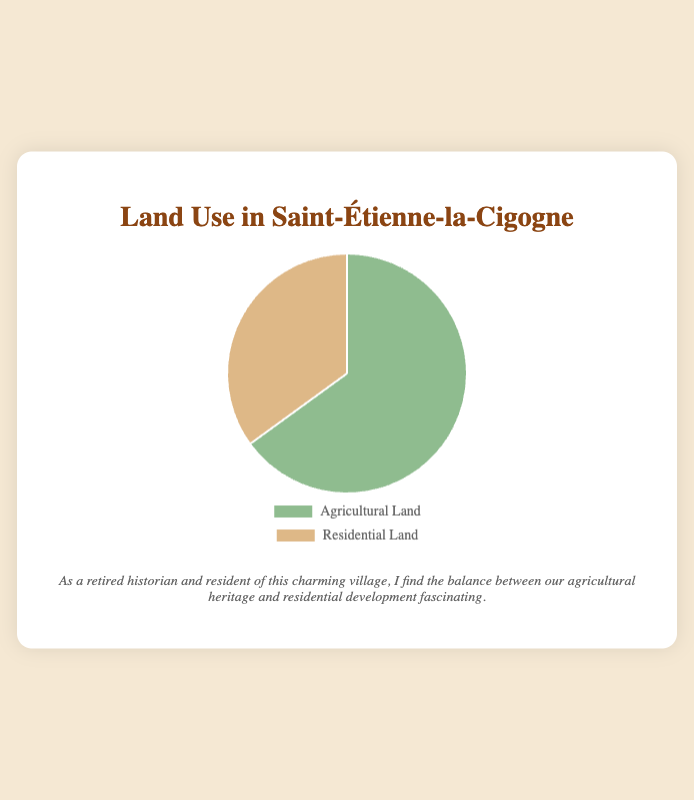what category occupies the majority of the land use in the village? The larger percentage between the two data points, 65% and 35%, represents the majority land use. Therefore, Agricultural Land occupies the majority as it has a larger percentage (65%).
Answer: Agricultural Land What is the percentage difference between Agricultural Land and Residential Land? Subtract the percentage of Residential Land (35%) from the percentage of Agricultural Land (65%). The calculation is 65% - 35% = 30%.
Answer: 30% If the total land area of the village is 200 hectares, how many hectares are used for Residential Land? Calculate 35% of 200 hectares. 35% of 200 is (35/100) * 200 = 70 hectares.
Answer: 70 hectares Which land use category is represented by the color green in the pie chart? According to the color coding specified, Agricultural Land is represented by the color green.
Answer: Agricultural Land What is the combined percentage of land used for Agricultural and Residential purposes? Add the percentage of Agricultural Land (65%) to the percentage of Residential Land (35%). The combined percentage is 65% + 35% = 100%.
Answer: 100% Is the percentage of Agricultural Land greater than twice the percentage of Residential Land? Calculate twice the percentage of Residential Land (35%) which is 2 * 35% = 70%. Compare this with the percentage of Agricultural Land (65%). Since 65% is less than 70%, the answer is no.
Answer: No Describe how the sectors for Agricultural and Residential land are visually different in the pie chart. The sector for Agricultural Land is likely larger in size than the sector for Residential Land since it represents 65% compared to 35%. Additionally, Agricultural Land is represented by the color green, whereas Residential Land is in brown.
Answer: Agricultural Land sector is larger and green; Residential Land sector is smaller and brown If a new development plans to convert 10% of the Agricultural Land to Residential Land, what will be the new percentages for each category? Current percentages are Agricultural Land 65% and Residential Land 35%. If 10% is moved from Agricultural to Residential, new calculations are: Agricultural Land 65% - 10% = 55%, Residential Land 35% + 10% = 45%.
Answer: Agricultural Land: 55%, Residential Land: 45% What is the difference in visual size between the sectors for Agricultural and Residential land use? The pie chart visually represents Agricultural Land with a larger sector compared to Residential Land, corresponding to 65% versus 35%. The difference in visual size corresponds to a difference in percentage, which is 65% - 35% = 30%.
Answer: 30% Which land use category could be considered dominant in this village? The land use category with the higher percentage is considered dominant. In this case, Agricultural Land has a higher percentage (65%) compared to Residential Land (35%).
Answer: Agricultural Land 